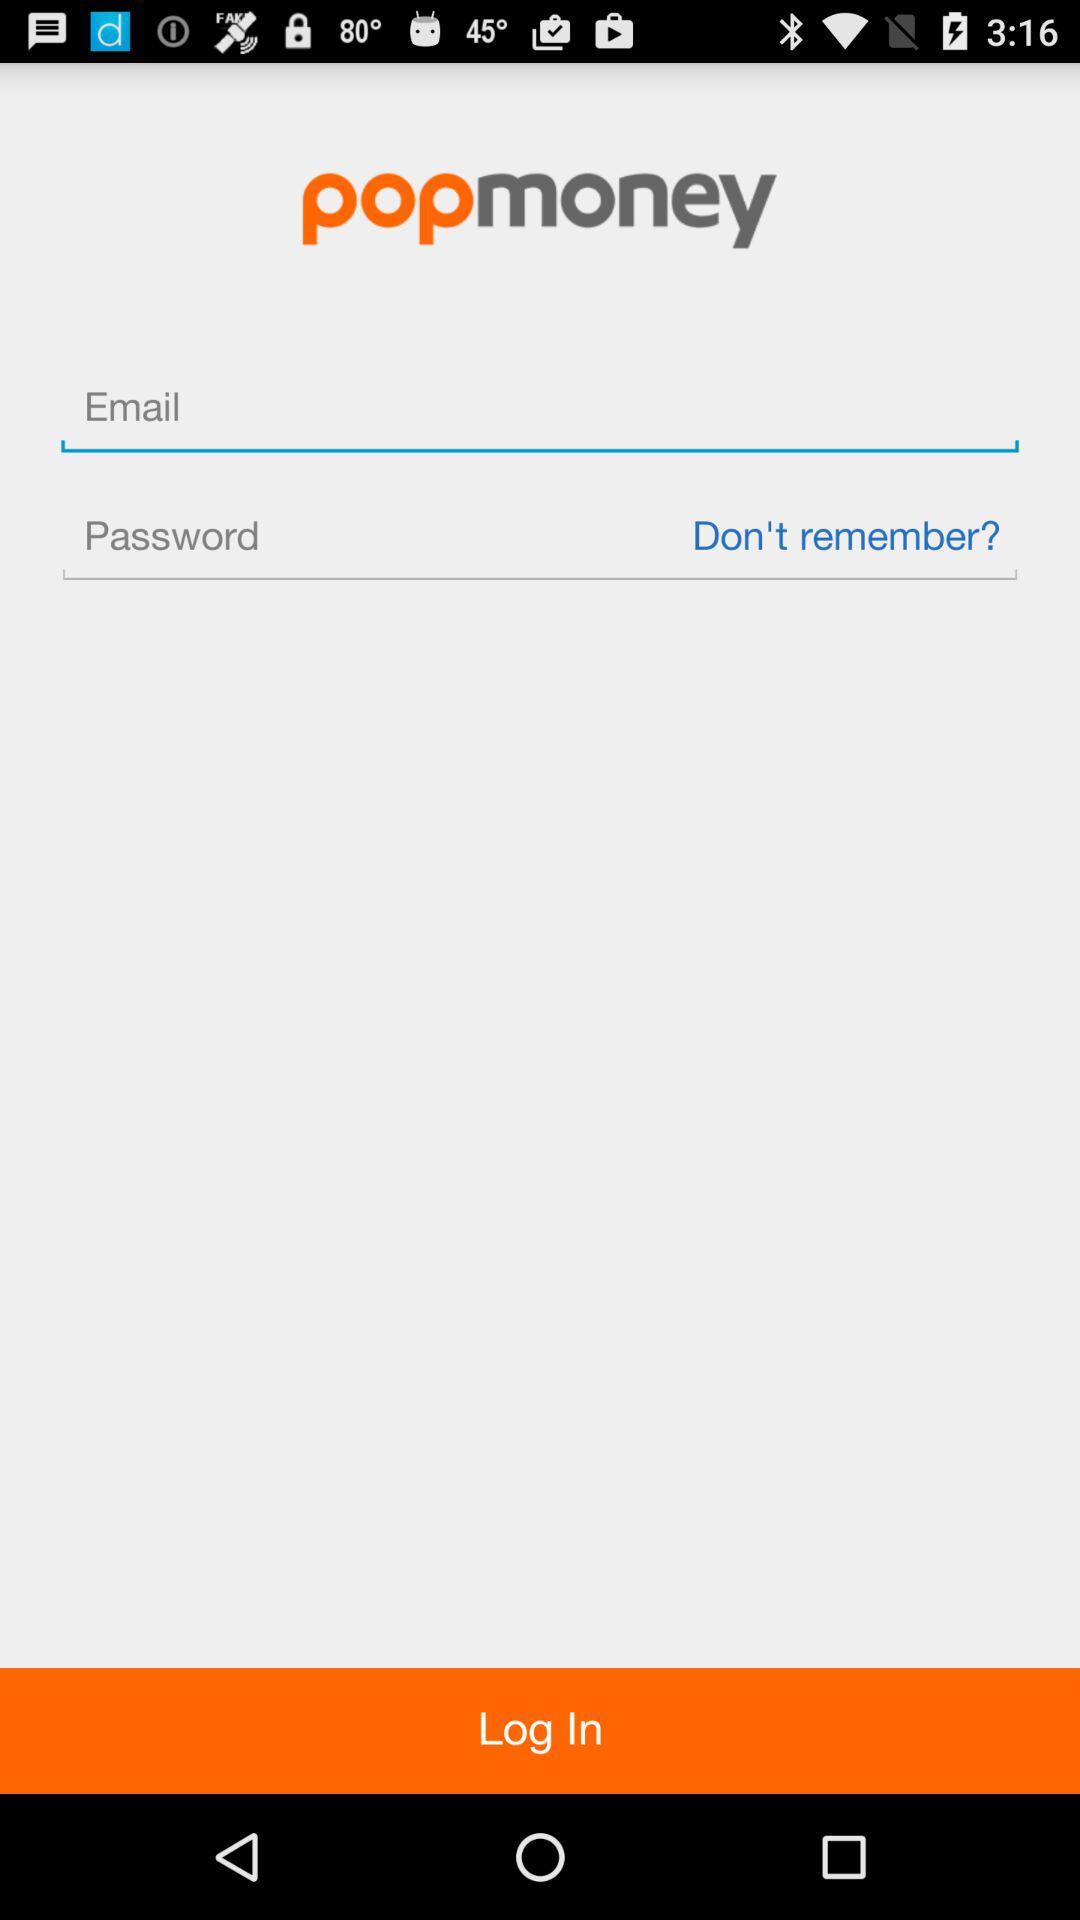What is the application name? The application name is "popmoney". 